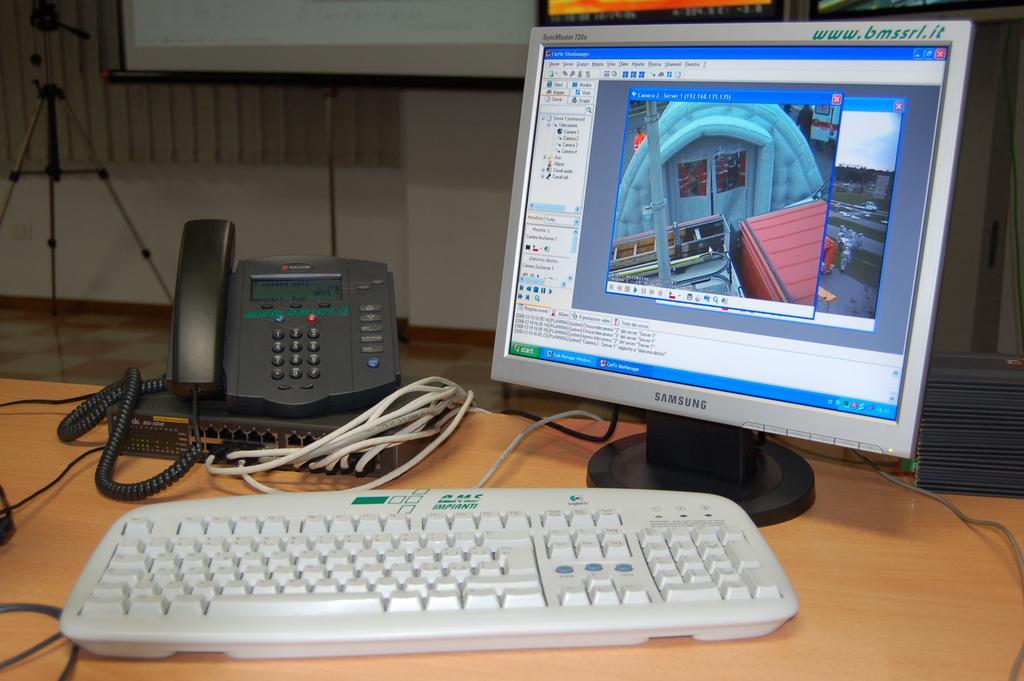In one or two sentences, can you explain what this image depicts? In this image, we can see a monitor, keyboard, telephone, cables and there is any other object on the table. In the background, there is a stand, board, some frames and a wall. 